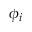Convert formula to latex. <formula><loc_0><loc_0><loc_500><loc_500>\phi _ { i }</formula> 